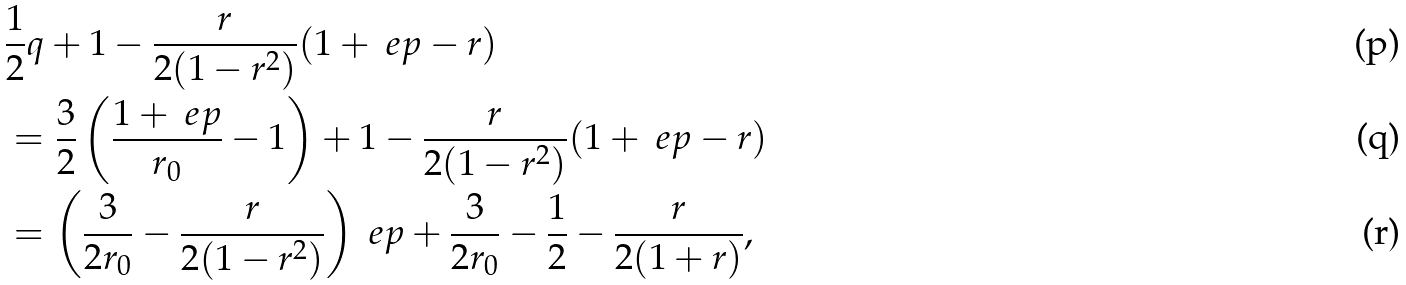Convert formula to latex. <formula><loc_0><loc_0><loc_500><loc_500>& \frac { 1 } { 2 } q + 1 - \frac { r } { 2 ( 1 - r ^ { 2 } ) } ( 1 + \ e p - r ) \\ & = \frac { 3 } { 2 } \left ( \frac { 1 + \ e p } { r _ { 0 } } - 1 \right ) + 1 - \frac { r } { 2 ( 1 - r ^ { 2 } ) } ( 1 + \ e p - r ) \\ & = \left ( \frac { 3 } { 2 r _ { 0 } } - \frac { r } { 2 ( 1 - r ^ { 2 } ) } \right ) \ e p + \frac { 3 } { 2 r _ { 0 } } - \frac { 1 } { 2 } - \frac { r } { 2 ( 1 + r ) } ,</formula> 